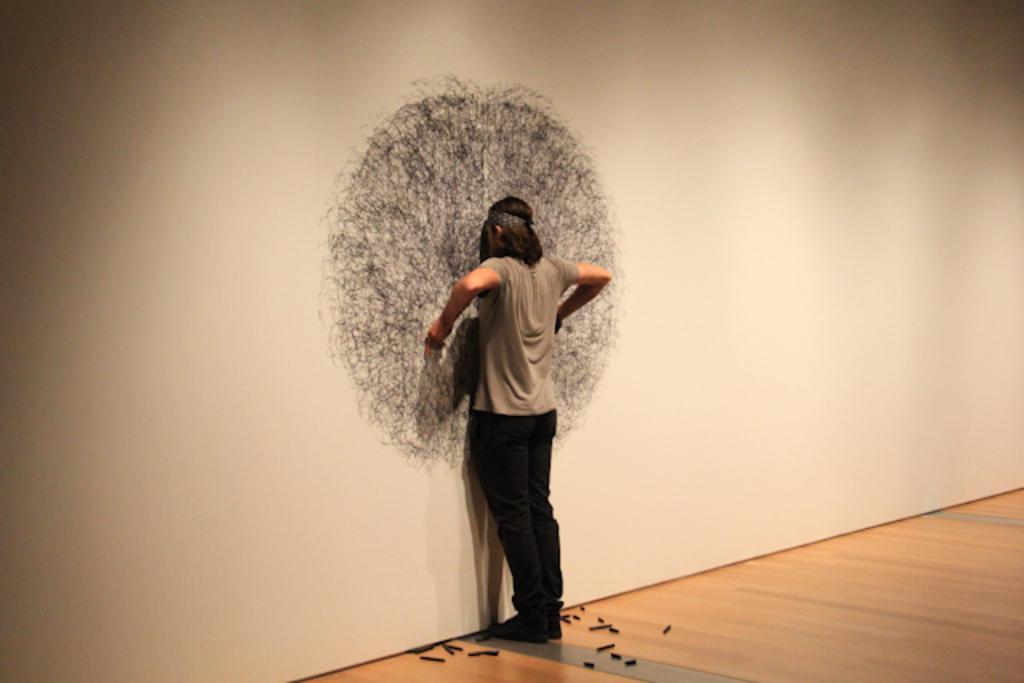How would you summarize this image in a sentence or two? This picture is clicked inside. On the left there is a person standing on the ground and there are some objects lying on the floor. In the background we can see the wall and sketch on the wall. 